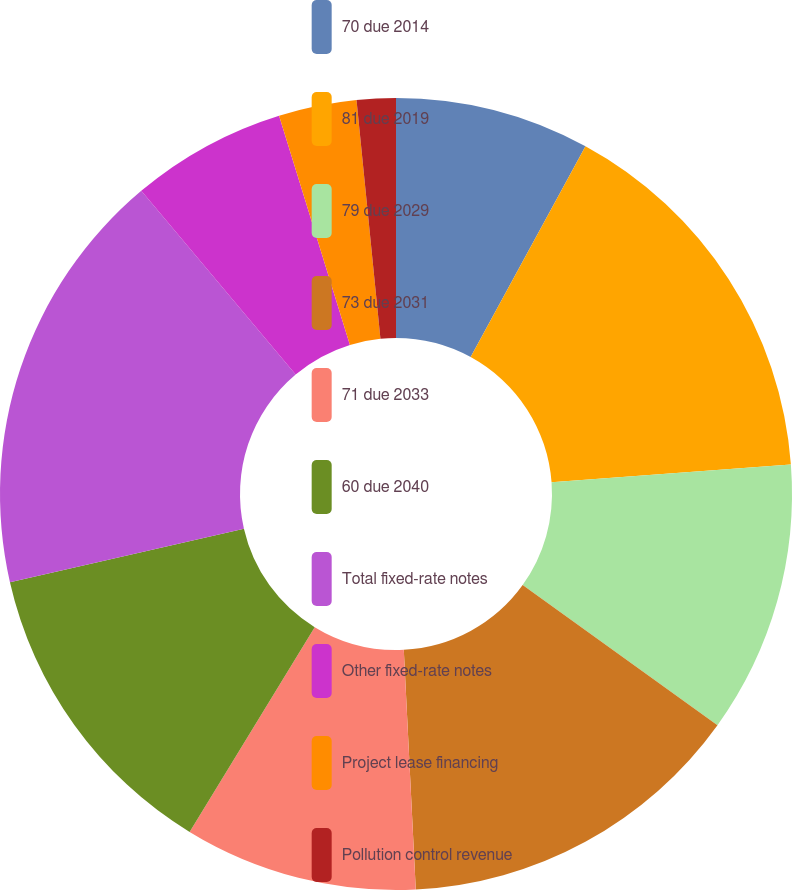<chart> <loc_0><loc_0><loc_500><loc_500><pie_chart><fcel>70 due 2014<fcel>81 due 2019<fcel>79 due 2029<fcel>73 due 2031<fcel>71 due 2033<fcel>60 due 2040<fcel>Total fixed-rate notes<fcel>Other fixed-rate notes<fcel>Project lease financing<fcel>Pollution control revenue<nl><fcel>7.94%<fcel>15.87%<fcel>11.11%<fcel>14.28%<fcel>9.52%<fcel>12.7%<fcel>17.45%<fcel>6.35%<fcel>3.18%<fcel>1.59%<nl></chart> 